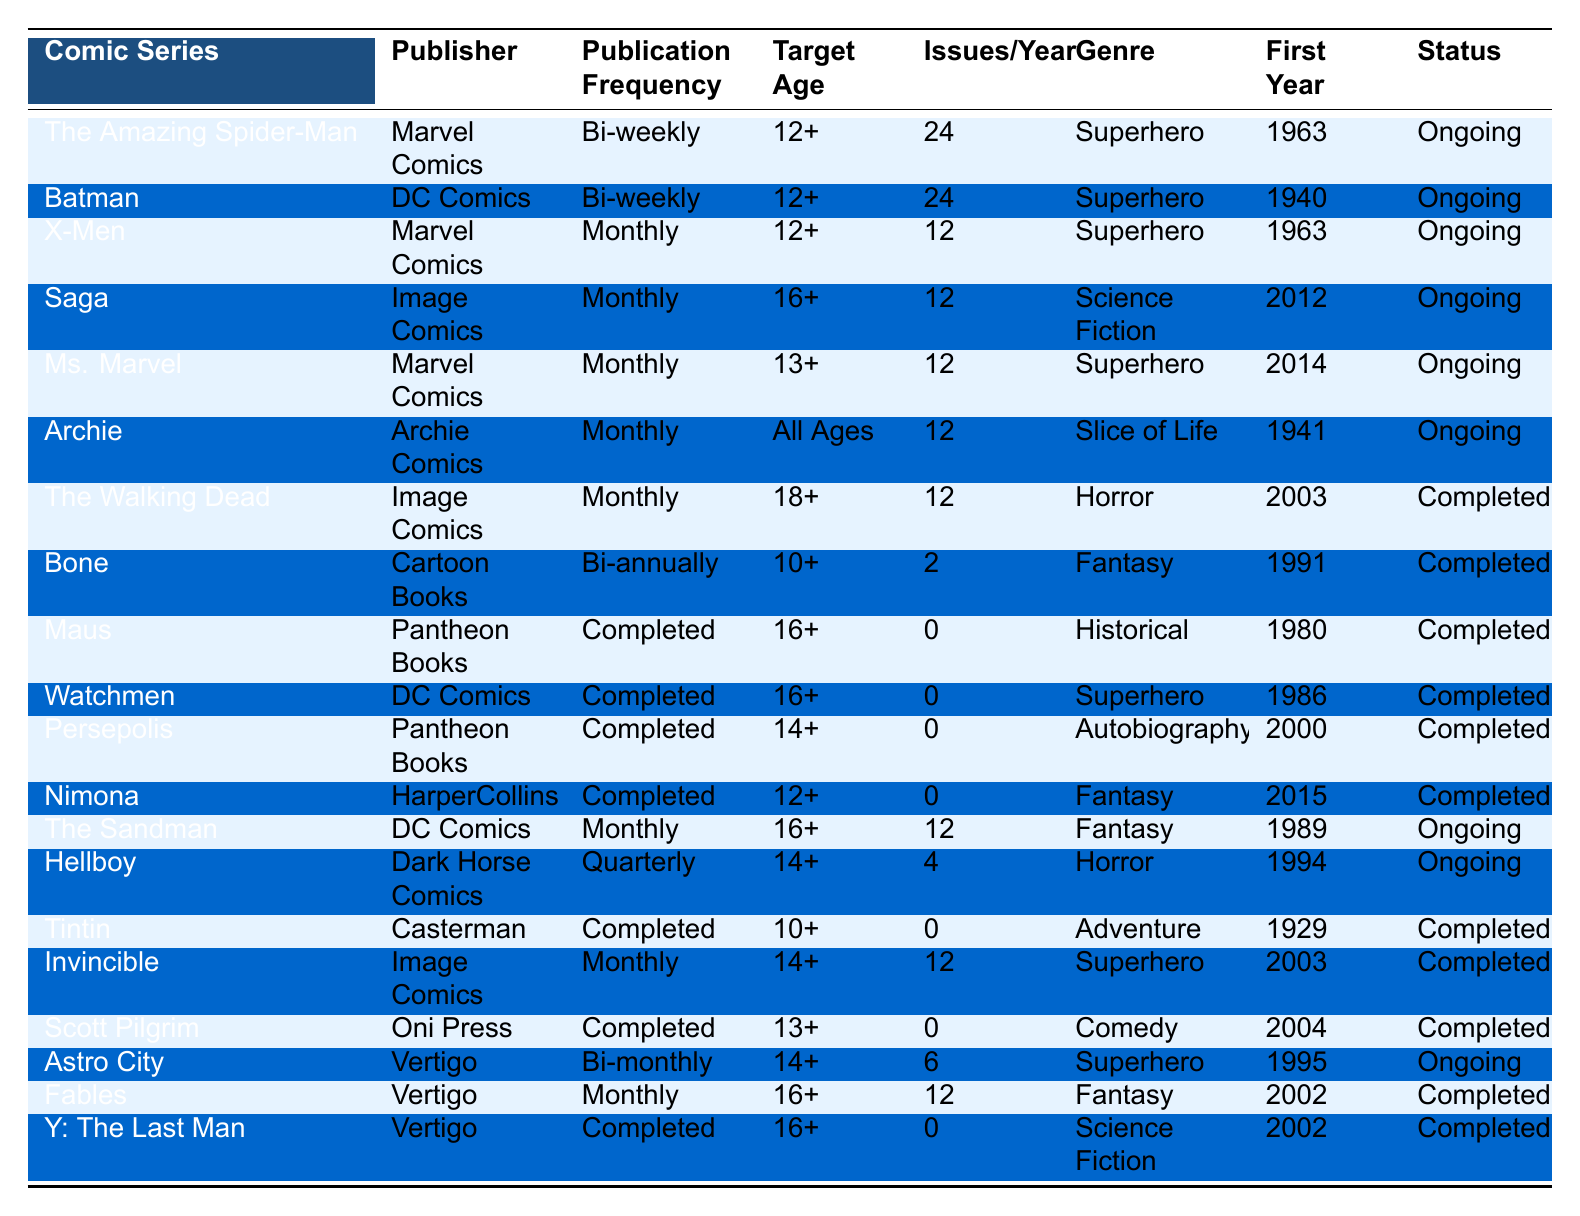What is the publication frequency of "The Amazing Spider-Man"? By locating "The Amazing Spider-Man" in the table, we find that its publication frequency is listed as "Bi-weekly".
Answer: Bi-weekly How many comic series are published monthly? The table shows a total of 9 comic series listed under "Publication Frequency" as "Monthly".
Answer: 9 Which comic series has the earliest first publication year? Scanning the "First Publication Year" column, "Tintin" is observed to have the year 1929, making it the earliest series.
Answer: Tintin Are there any comic series that are completed and have a publication frequency? "The Walking Dead" has a publication frequency of "Monthly" but is marked as completed. This means that there is at least one series that meets the criteria.
Answer: Yes Which genre has the highest number of entries among the comic series? Checking the "Genre" column, "Superhero" appears 6 times, more than any other genre listed in the table.
Answer: Superhero What is the average number of issues published per year for ongoing series? Summing the issues per year for ongoing series: Spider-Man (24), Batman (24), X-Men (12), Saga (12), Ms. Marvel (12), Archie (12), Sandman (12), Hellboy (4), and Astro City (6) results in: 24 + 24 + 12 + 12 + 12 + 12 + 12 + 4 + 6 = 120. There are 9 ongoing series, so the average is 120/9 = 13.33.
Answer: Approximately 13 How many superhero comic series are still ongoing? Looking at the ongoing series, "The Amazing Spider-Man", "Batman", "X-Men", "Saga", "Ms. Marvel", "Archie", "The Sandman", "Hellboy", and "Astro City" are identified, resulting in 8 ongoing superhero series.
Answer: 8 Is "Maus" ongoing? In the table, "Maus" is marked as "Completed", indicating that it is not ongoing.
Answer: No Which comic series has the highest average issues published per year? The highest average issues per year is 24, seen with both "The Amazing Spider-Man" and "Batman".
Answer: The Amazing Spider-Man and Batman What publication frequency does "Invincible" have and what is its current status? "Invincible" is listed under "Publication Frequency" as "Monthly" and its current status is marked as "Completed".
Answer: Monthly, Completed How many comic series target the age group of 16+ and are still ongoing? A review of the table shows that "Saga", "The Sandman", and "Hellboy" are the only ongoing series aimed at the 16+ age group, resulting in a total of 3.
Answer: 3 